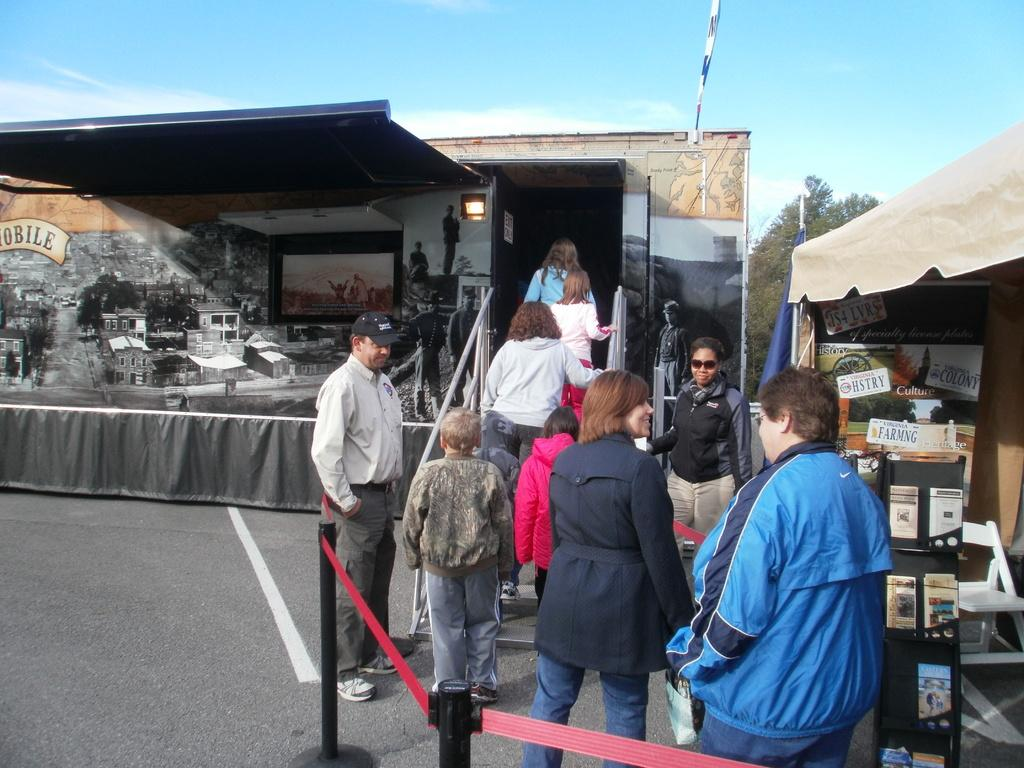<image>
Render a clear and concise summary of the photo. A rack in the tent includes an ad for Virginia farming and history license plates. 